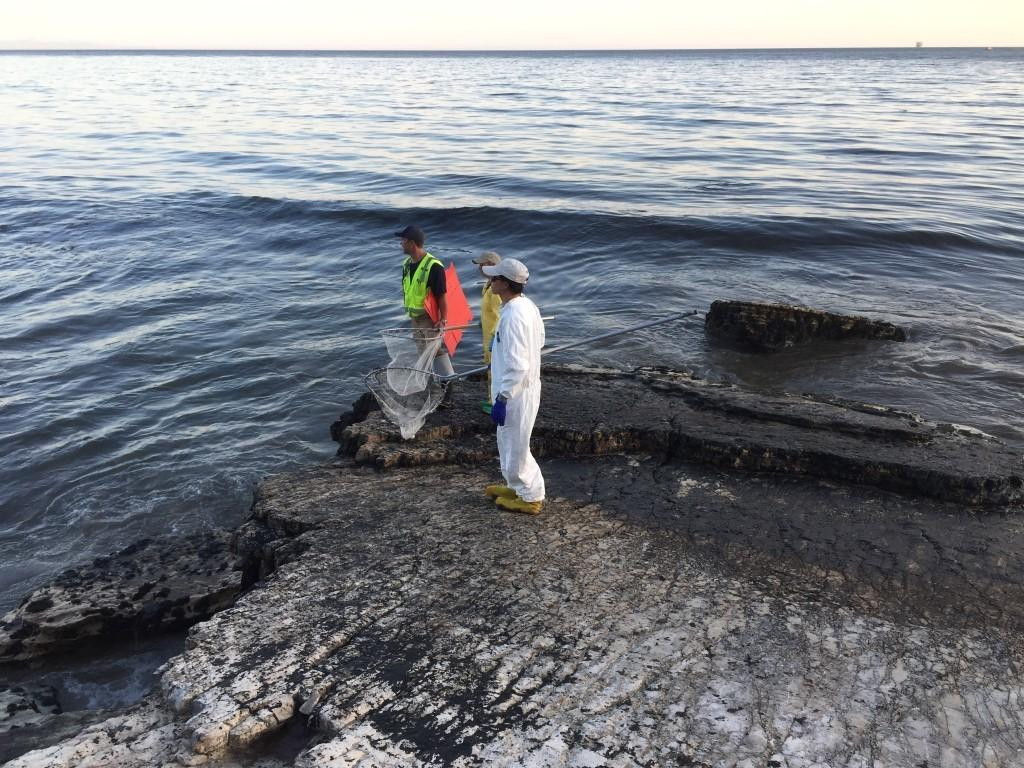What type of surface is visible in the image? There is ground visible in the image. What are the people on the ground doing? The people are standing on the ground and holding nets in their hands. What can be seen in the background of the image? There is water and the sky visible in the background of the image. What type of wall can be seen in the image? There is no wall present in the image. Can you describe the cave in the image? There is no cave present in the image. 